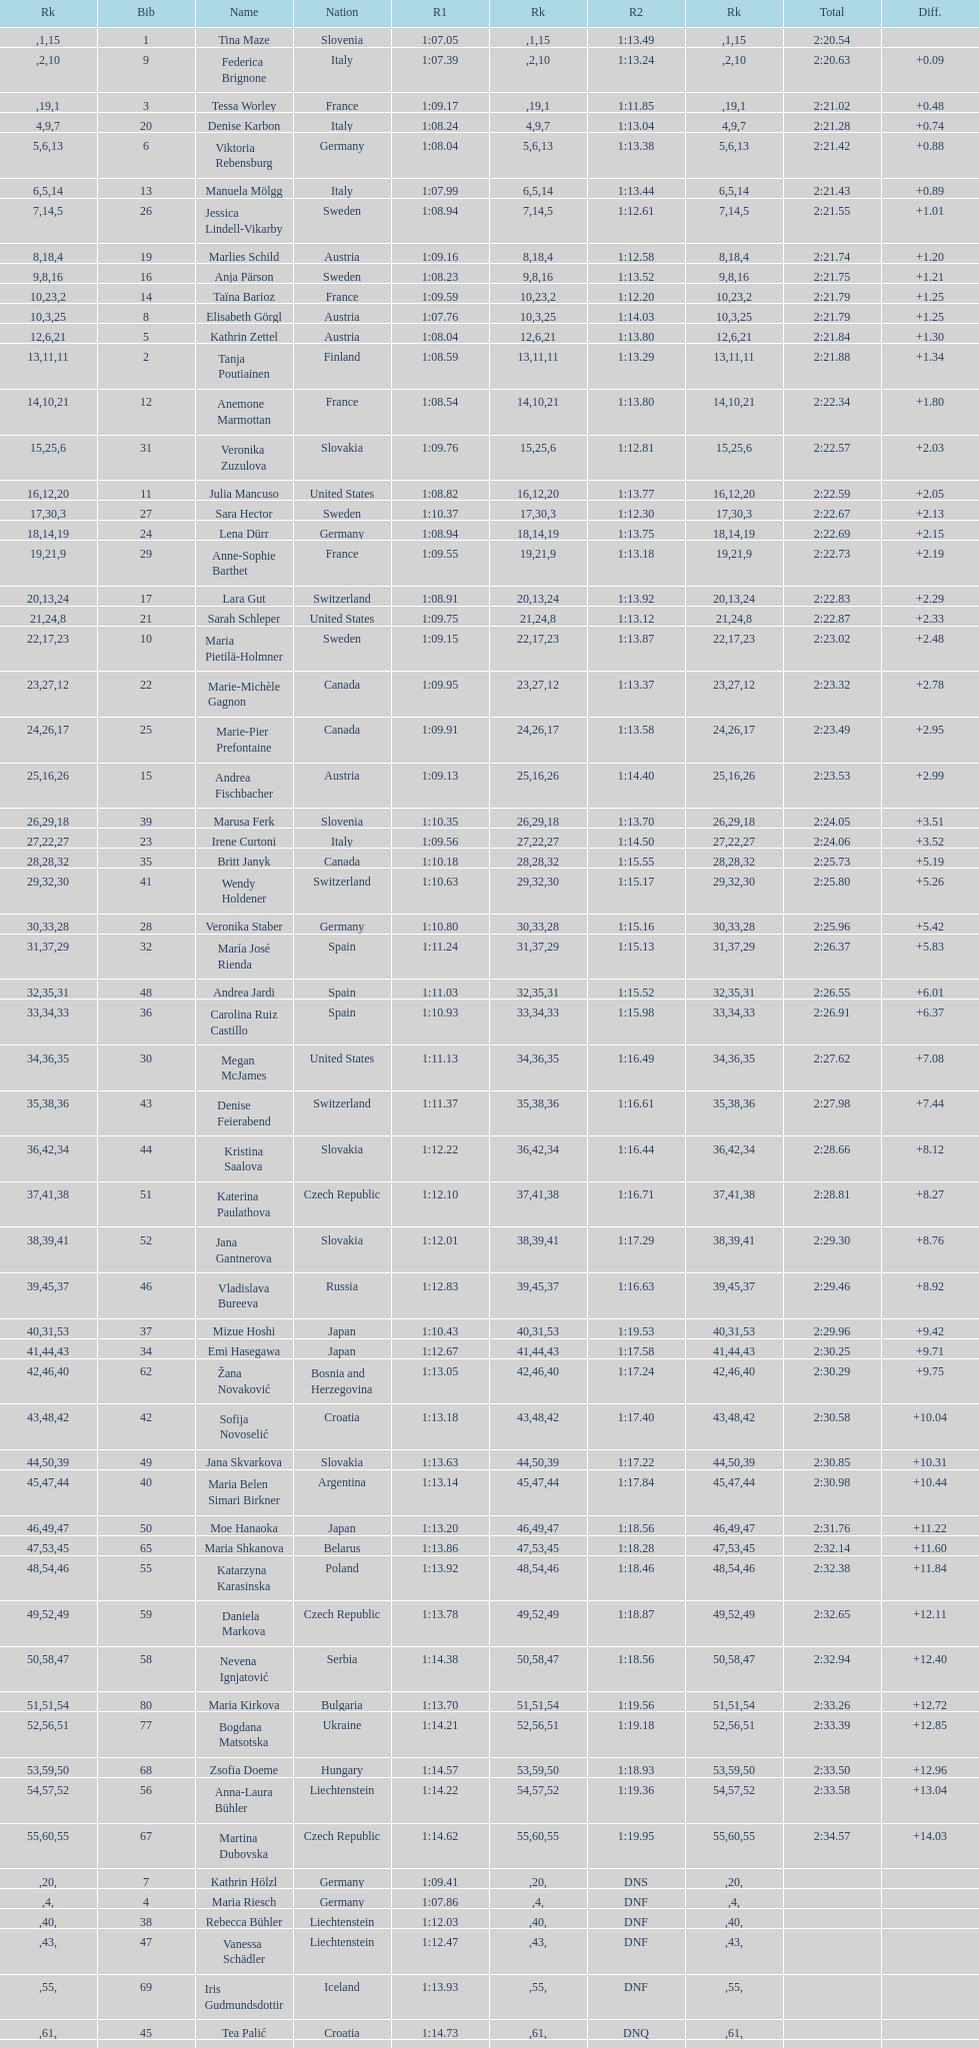What is the last nation to be ranked? Czech Republic. 